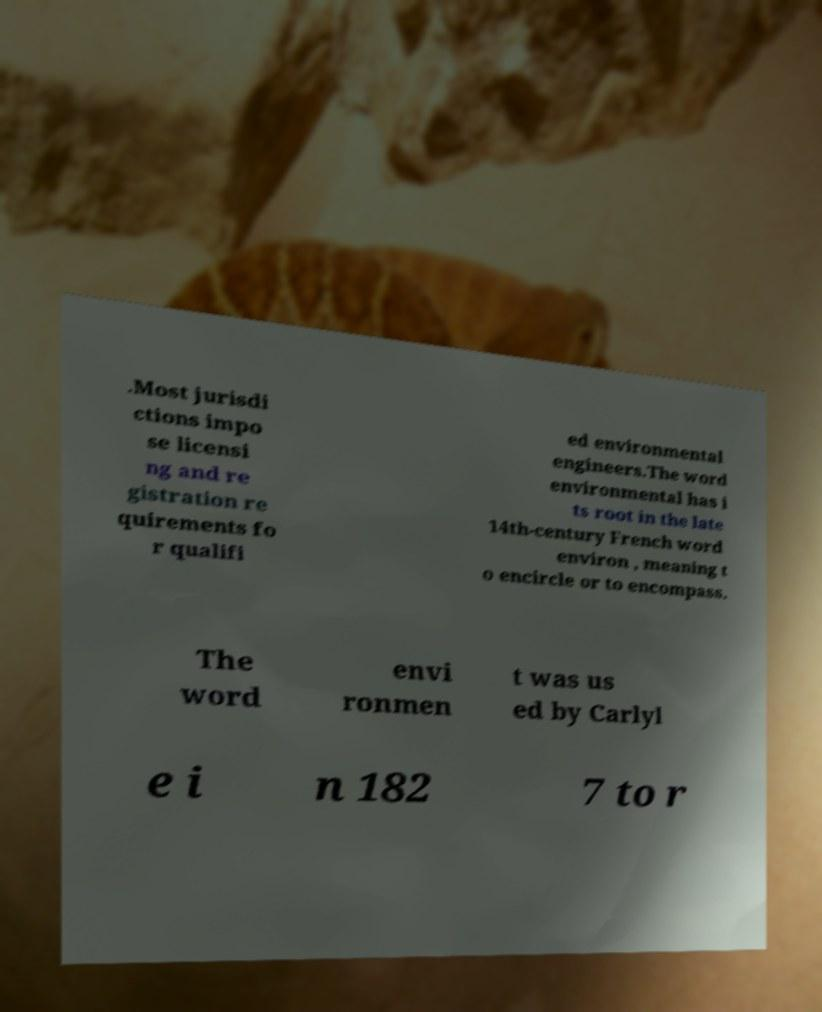There's text embedded in this image that I need extracted. Can you transcribe it verbatim? .Most jurisdi ctions impo se licensi ng and re gistration re quirements fo r qualifi ed environmental engineers.The word environmental has i ts root in the late 14th-century French word environ , meaning t o encircle or to encompass. The word envi ronmen t was us ed by Carlyl e i n 182 7 to r 